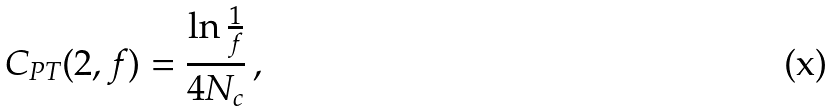<formula> <loc_0><loc_0><loc_500><loc_500>C _ { P T } ( 2 , f ) = \frac { \ln \frac { 1 } { f } } { 4 N _ { c } } \, ,</formula> 